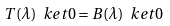<formula> <loc_0><loc_0><loc_500><loc_500>T ( \lambda ) \ k e t { 0 } = B ( \lambda ) \ k e t { 0 }</formula> 